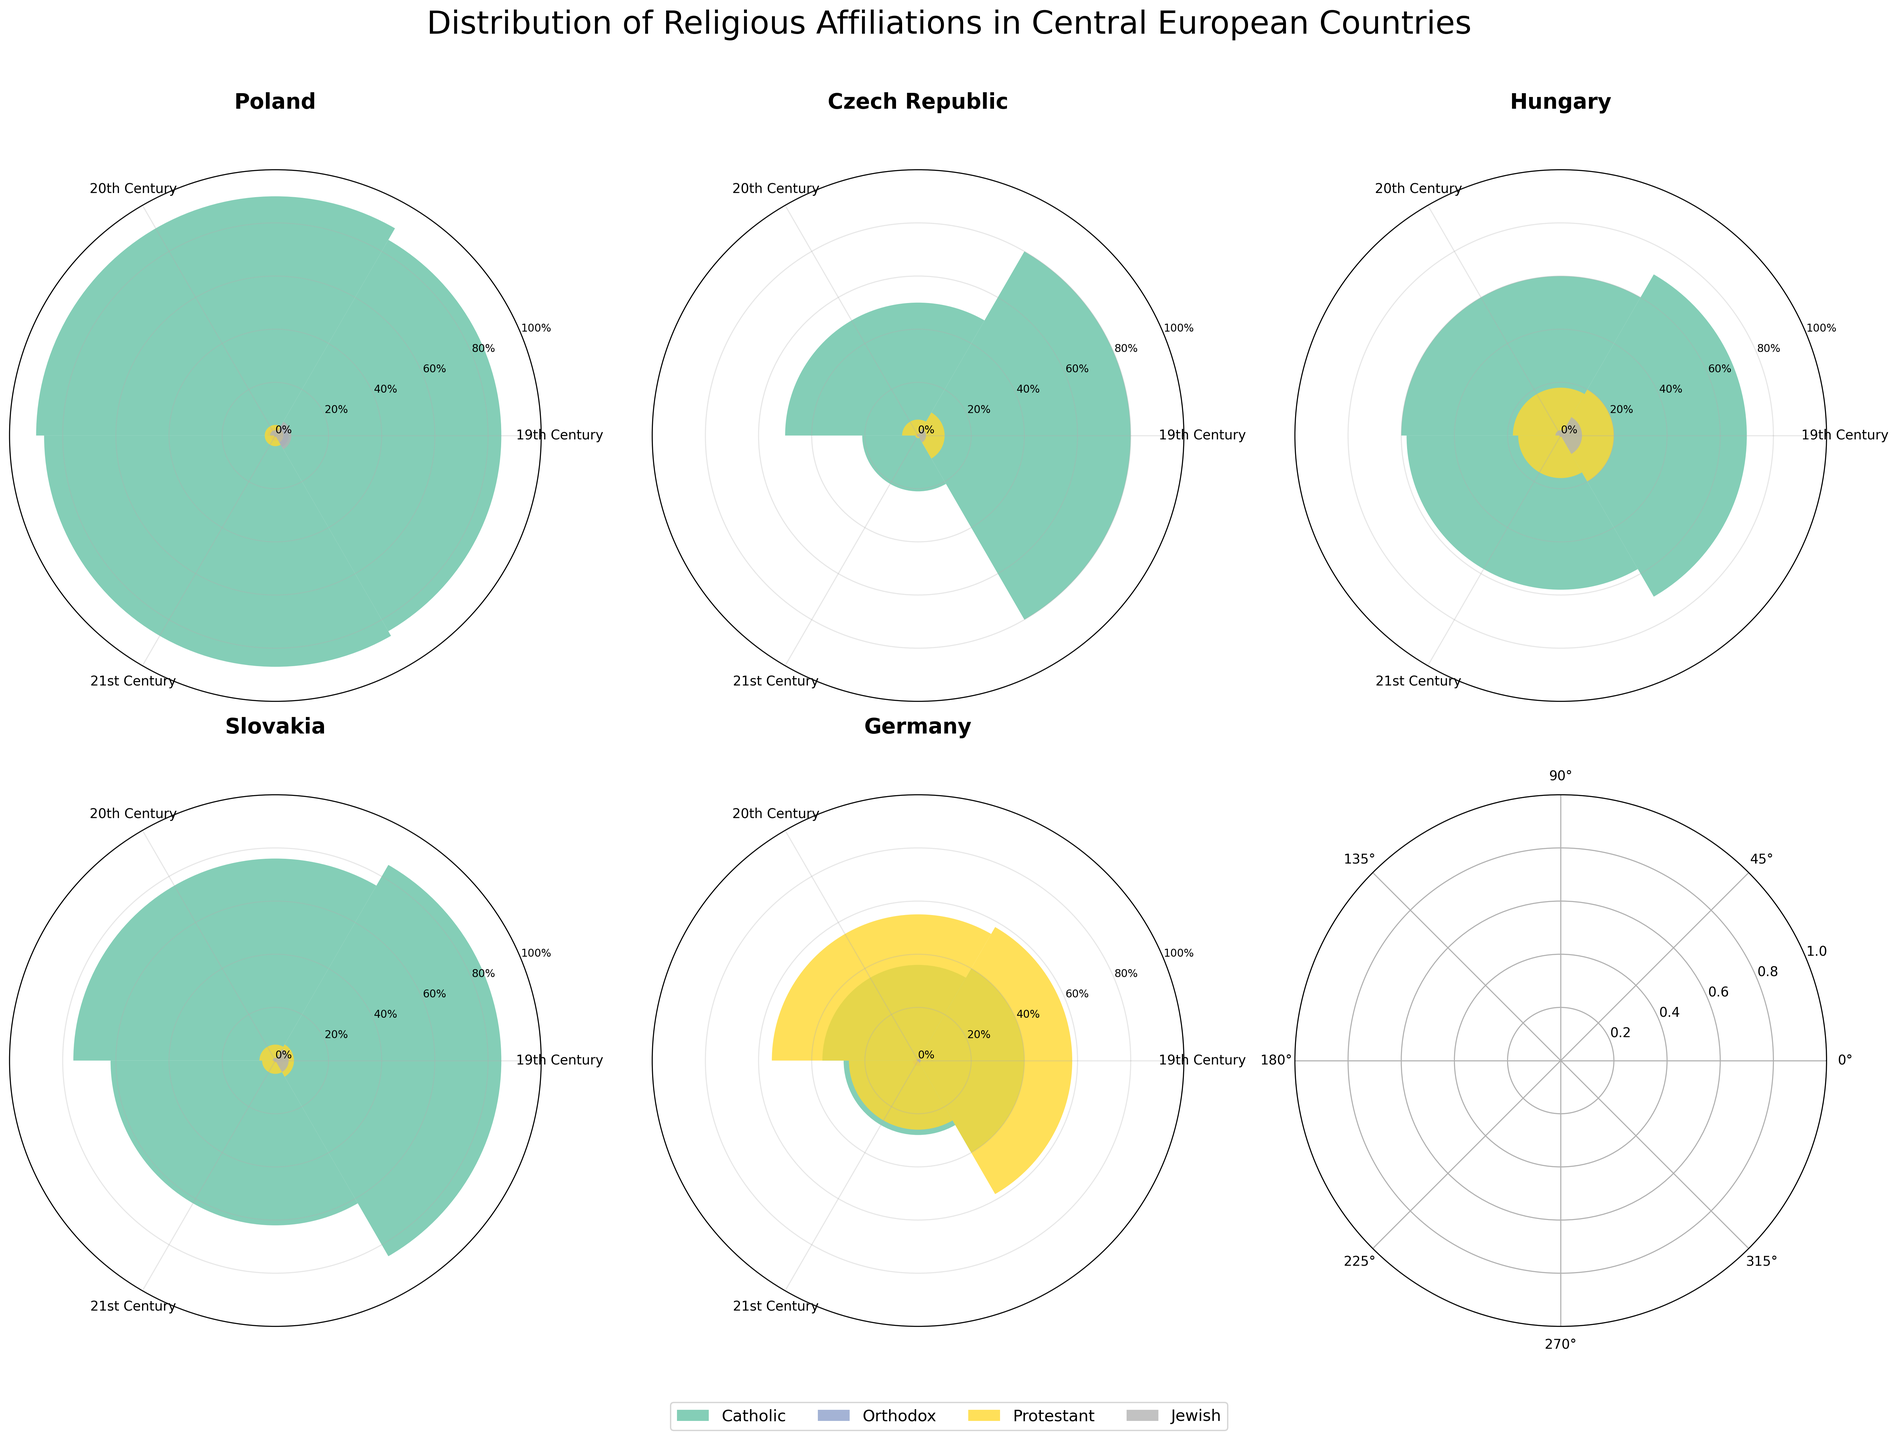What does the title of the polar chart indicate? The title of the polar chart provides an overview of the data being visualized. It states that the chart shows the distribution of religious affiliations in Central European countries.
Answer: Distribution of Religious Affiliations in Central European Countries Which country has the highest percentage of Catholics in the 21st century? Look at the values for the 21st century in each polar chart. Poland has the highest percentage with 87%.
Answer: Poland Compare the percentage of Jews in Germany during the 19th and 21st centuries. Find the values for Jews in Germany in the respective centuries and compare them. The value decreases from 1% in the 19th century to 0.2% in the 21st century.
Answer: The percentage decreased from 1% to 0.2% Which country experienced the most significant decline in the percentage of Catholics from the 19th to the 21st century? Calculate the difference in the percentage of Catholics between the 19th and 21st centuries for each country. The Czech Republic shows the largest decrease, from 80% to 21%, a decline of 59%.
Answer: Czech Republic What is the general trend for the Protestant population in Germany from the 19th to the 21st century? Observe the values for Protestants in Germany across the three centuries: 58% in the 19th century, 55% in the 20th century, and 26% in the 21st century. The trend shows a general decline.
Answer: Declining trend In which century did Hungary have the highest percentage of Protestants? Look at Hungary's values for Protestants in each century. The highest percentage is in the 19th century with 20%.
Answer: 19th century Which two countries had similar percentages for the Orthodox population in the 21st century? Compare the values for the Orthodox population in the 21st century across all countries. Both Poland and the Czech Republic have 0.5%.
Answer: Poland and the Czech Republic How did the Jewish population change in Slovakia across the centuries? Check the values for Jews in Slovakia in the respective centuries. The percentages go from 5% in the 19th century to 1% in the 20th century and 0.5% in the 21st century.
Answer: Declined consistently 